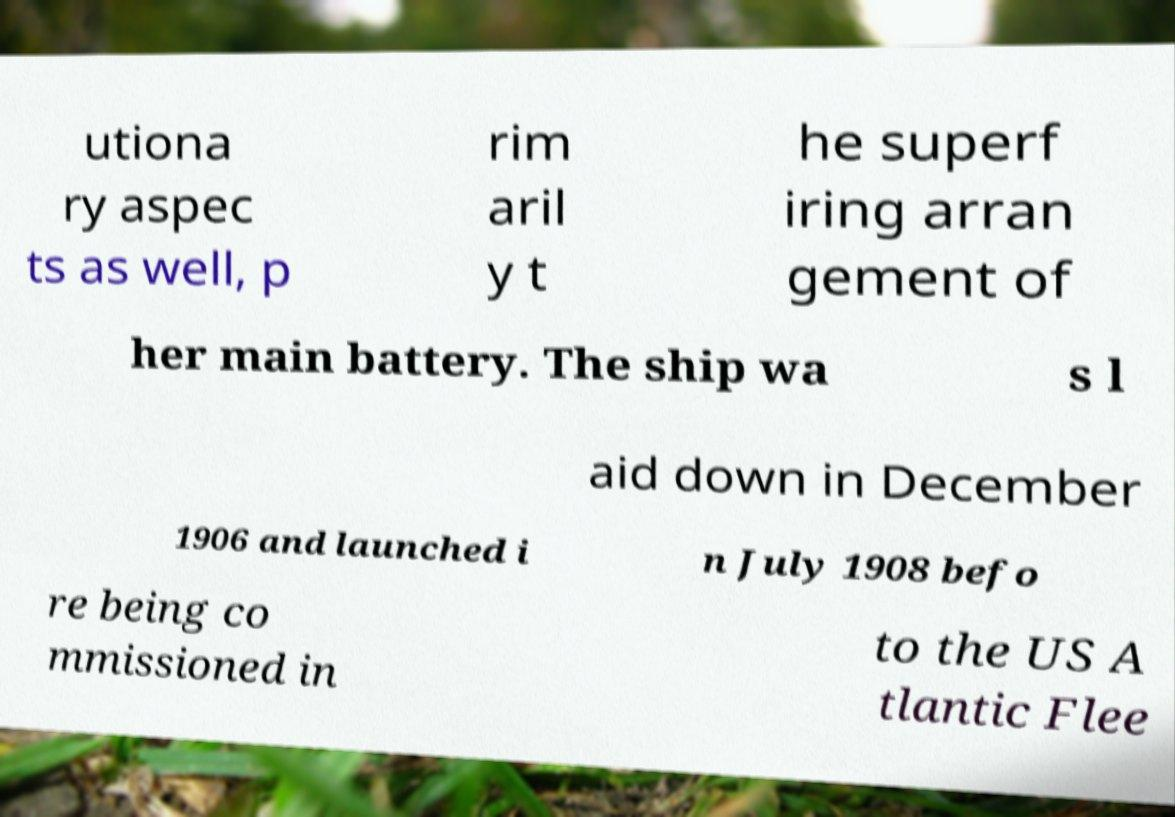I need the written content from this picture converted into text. Can you do that? utiona ry aspec ts as well, p rim aril y t he superf iring arran gement of her main battery. The ship wa s l aid down in December 1906 and launched i n July 1908 befo re being co mmissioned in to the US A tlantic Flee 